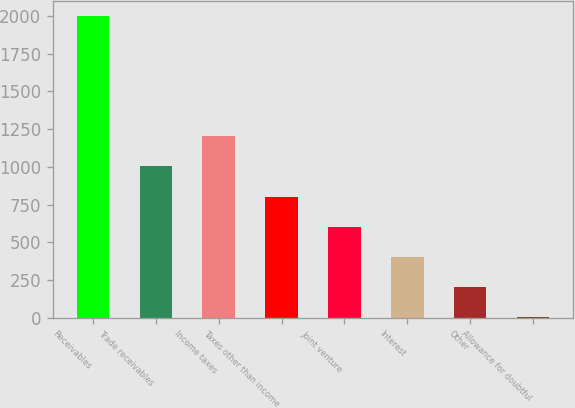<chart> <loc_0><loc_0><loc_500><loc_500><bar_chart><fcel>Receivables<fcel>Trade receivables<fcel>Income taxes<fcel>Taxes other than income<fcel>Joint venture<fcel>Interest<fcel>Other<fcel>Allowance for doubtful<nl><fcel>2001<fcel>1002.4<fcel>1202.12<fcel>802.68<fcel>602.96<fcel>403.24<fcel>203.52<fcel>3.8<nl></chart> 